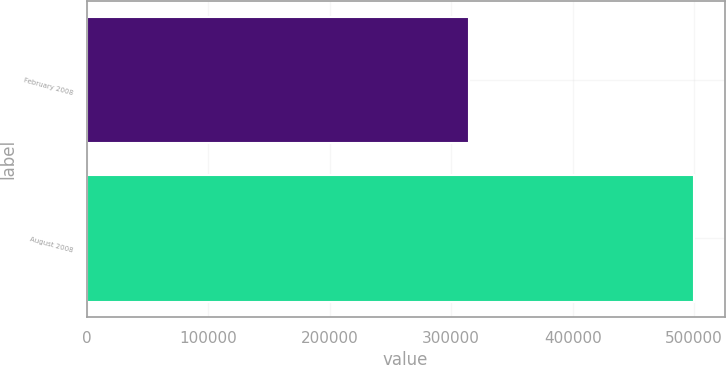Convert chart to OTSL. <chart><loc_0><loc_0><loc_500><loc_500><bar_chart><fcel>February 2008<fcel>August 2008<nl><fcel>314389<fcel>500000<nl></chart> 